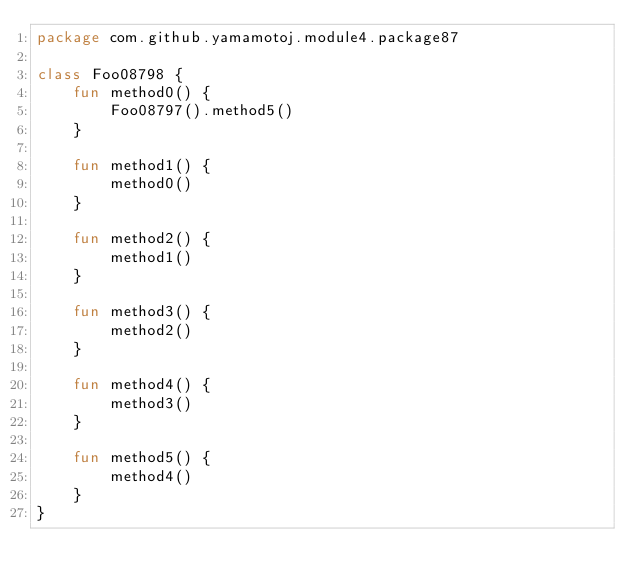Convert code to text. <code><loc_0><loc_0><loc_500><loc_500><_Kotlin_>package com.github.yamamotoj.module4.package87

class Foo08798 {
    fun method0() {
        Foo08797().method5()
    }

    fun method1() {
        method0()
    }

    fun method2() {
        method1()
    }

    fun method3() {
        method2()
    }

    fun method4() {
        method3()
    }

    fun method5() {
        method4()
    }
}
</code> 